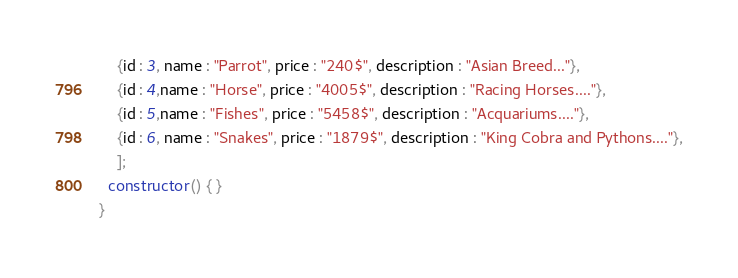Convert code to text. <code><loc_0><loc_0><loc_500><loc_500><_TypeScript_>    {id : 3, name : "Parrot", price : "240$", description : "Asian Breed..."},
    {id : 4,name : "Horse", price : "4005$", description : "Racing Horses...."},
    {id : 5,name : "Fishes", price : "5458$", description : "Acquariums...."},
    {id : 6, name : "Snakes", price : "1879$", description : "King Cobra and Pythons...."},
    ];
  constructor() { }
}
</code> 